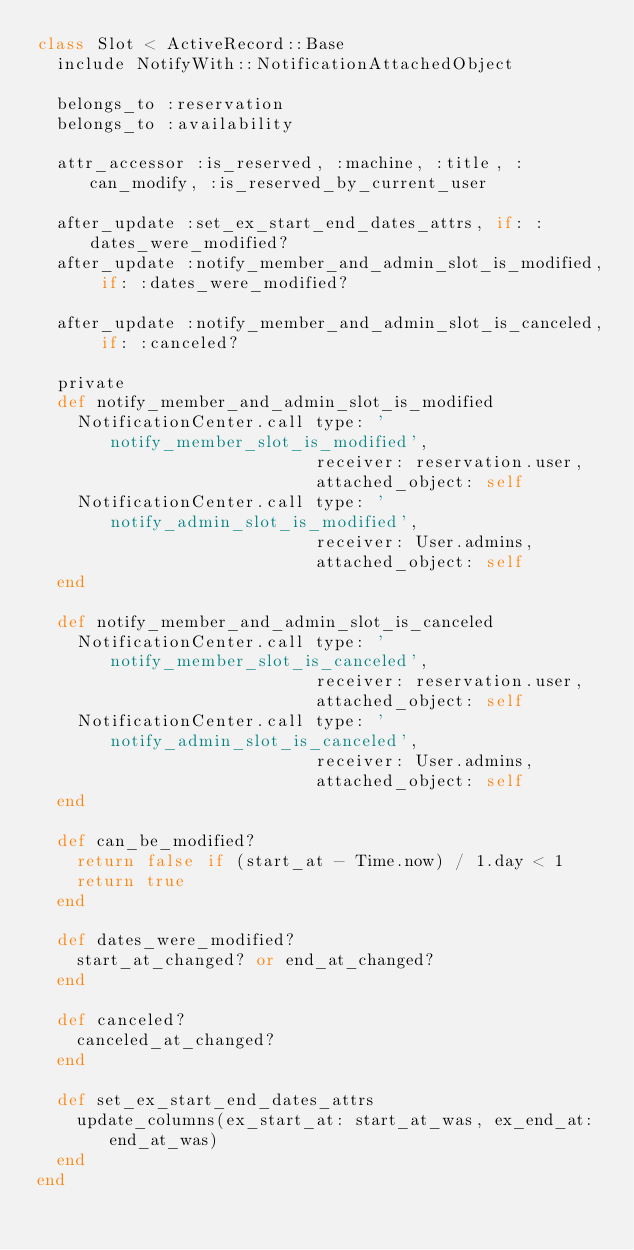Convert code to text. <code><loc_0><loc_0><loc_500><loc_500><_Ruby_>class Slot < ActiveRecord::Base
  include NotifyWith::NotificationAttachedObject

  belongs_to :reservation
  belongs_to :availability

  attr_accessor :is_reserved, :machine, :title, :can_modify, :is_reserved_by_current_user

  after_update :set_ex_start_end_dates_attrs, if: :dates_were_modified?
  after_update :notify_member_and_admin_slot_is_modified, if: :dates_were_modified?

  after_update :notify_member_and_admin_slot_is_canceled, if: :canceled?

  private
  def notify_member_and_admin_slot_is_modified
    NotificationCenter.call type: 'notify_member_slot_is_modified',
                            receiver: reservation.user,
                            attached_object: self
    NotificationCenter.call type: 'notify_admin_slot_is_modified',
                            receiver: User.admins,
                            attached_object: self
  end

  def notify_member_and_admin_slot_is_canceled
    NotificationCenter.call type: 'notify_member_slot_is_canceled',
                            receiver: reservation.user,
                            attached_object: self
    NotificationCenter.call type: 'notify_admin_slot_is_canceled',
                            receiver: User.admins,
                            attached_object: self
  end

  def can_be_modified?
    return false if (start_at - Time.now) / 1.day < 1
    return true
  end

  def dates_were_modified?
    start_at_changed? or end_at_changed?
  end

  def canceled?
    canceled_at_changed?
  end

  def set_ex_start_end_dates_attrs
    update_columns(ex_start_at: start_at_was, ex_end_at: end_at_was)
  end
end
</code> 